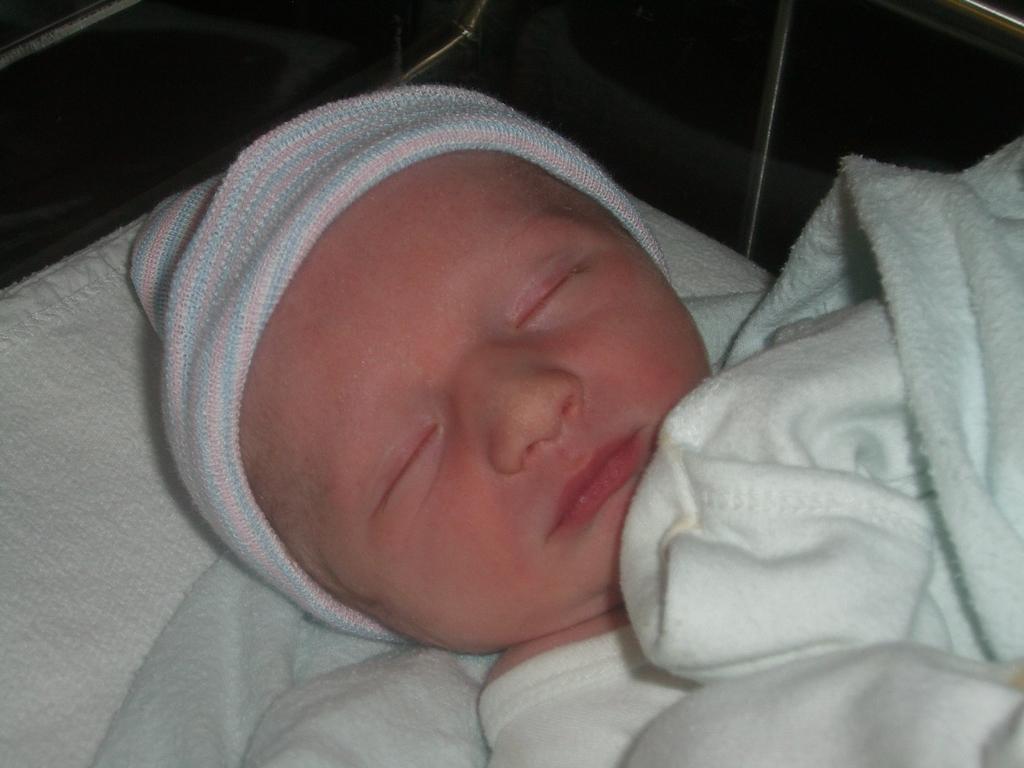How would you summarize this image in a sentence or two? In this image, we can see a kid, on the kid, we can see the white color blanket. In the background, we can see white color and black color. 